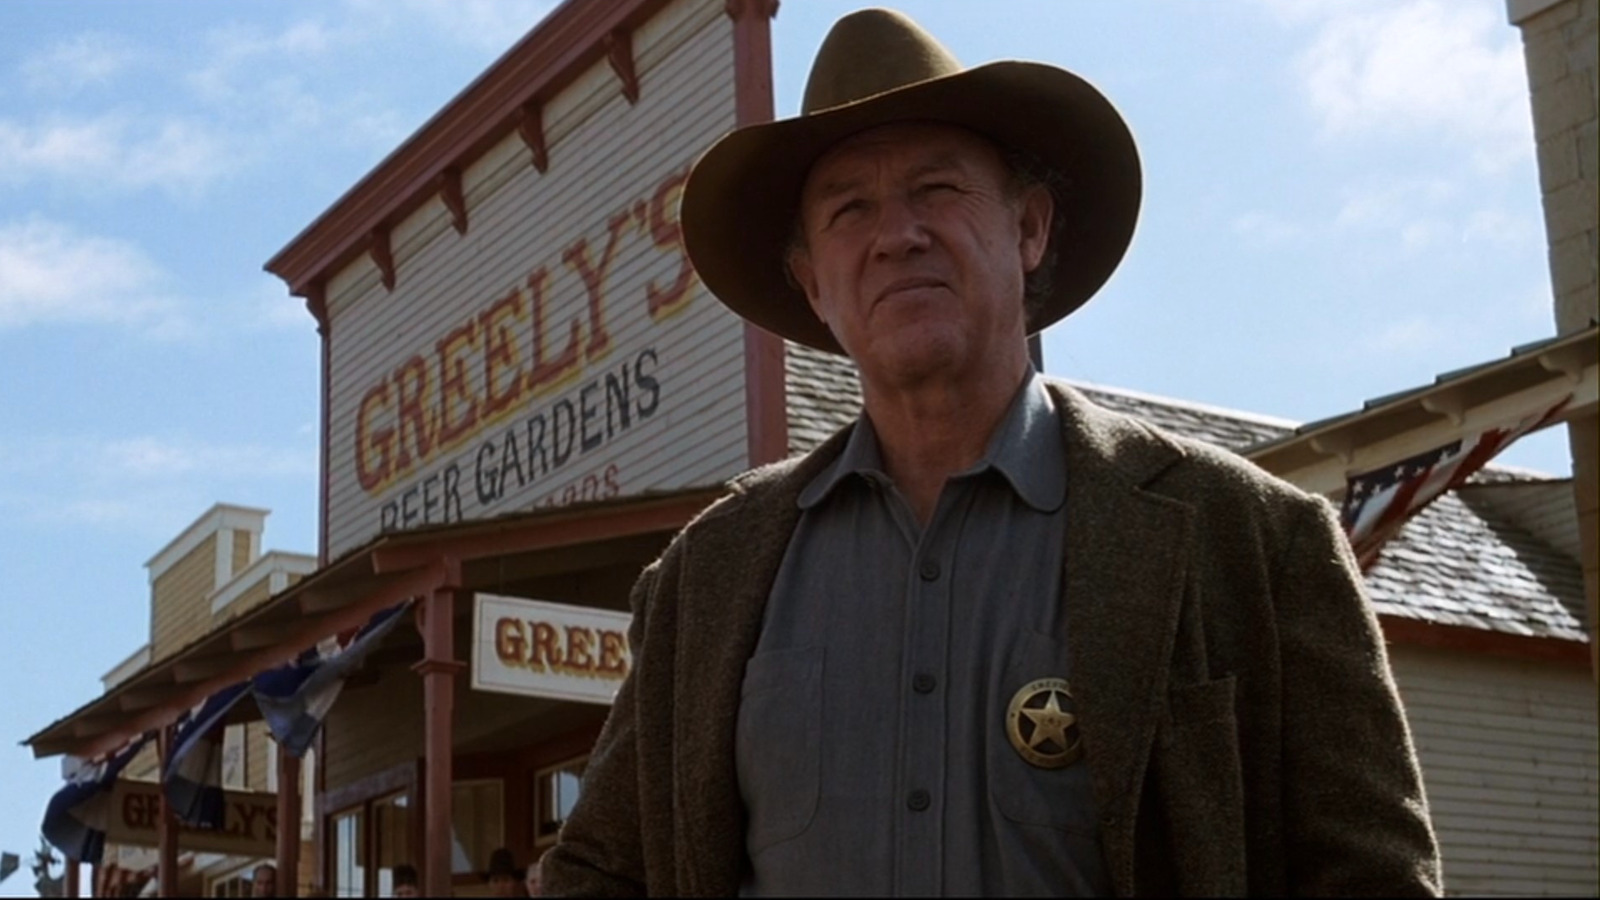How does the actor's expression and body language contribute to the scene? Gene Hackman's serious expression and firm stance contribute significantly to the scene, portraying a character of authority and determination. His direct gaze and the stern set of his mouth suggest he is a figure of significance, potentially facing a challenge or making an important decision. This body language and facial expression help to establish a tense and engaging narrative crucial to the film's storyline. 